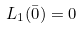Convert formula to latex. <formula><loc_0><loc_0><loc_500><loc_500>L _ { 1 } ( { \bar { 0 } } ) = 0</formula> 